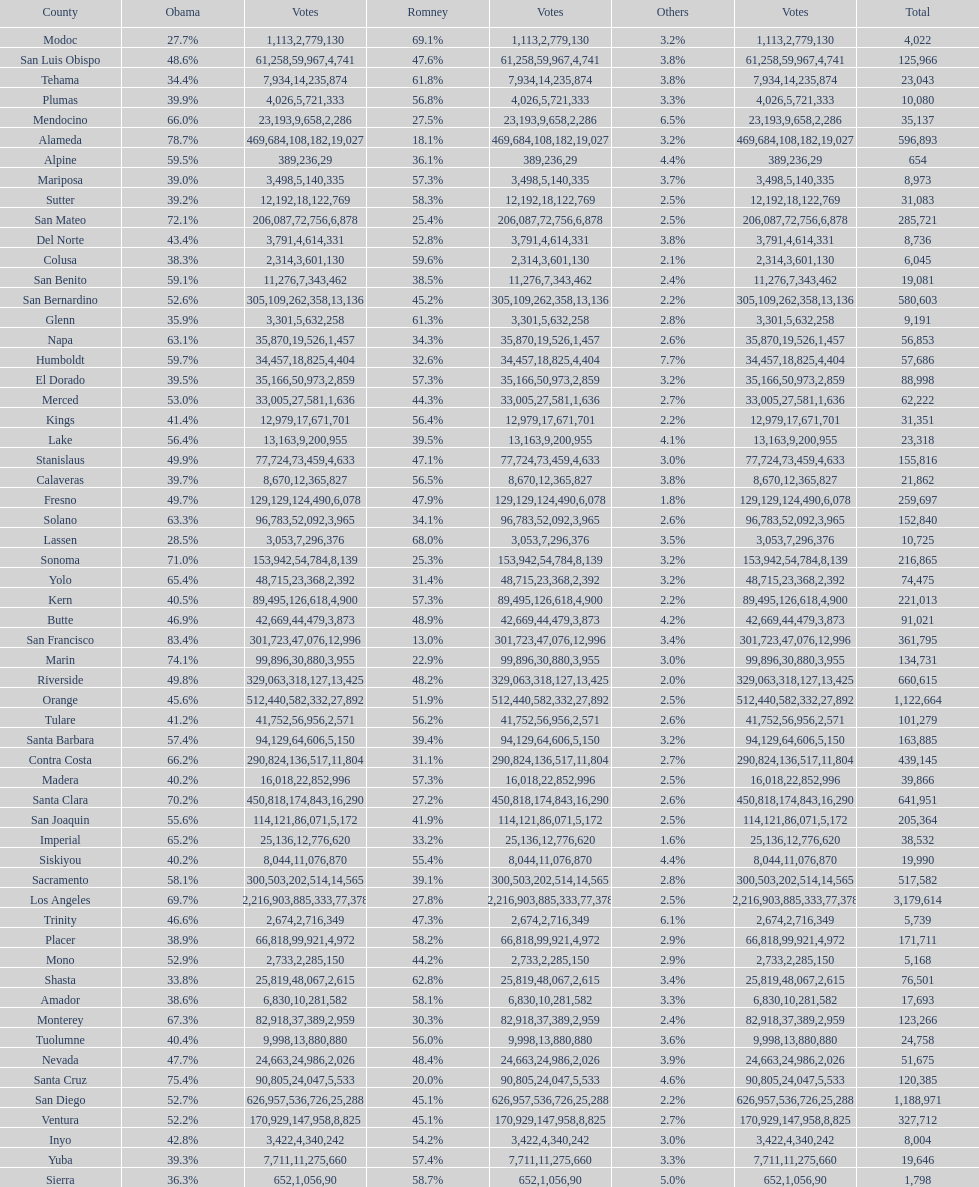Which county had the lower percentage votes for obama: amador, humboldt, or lake? Amador. 